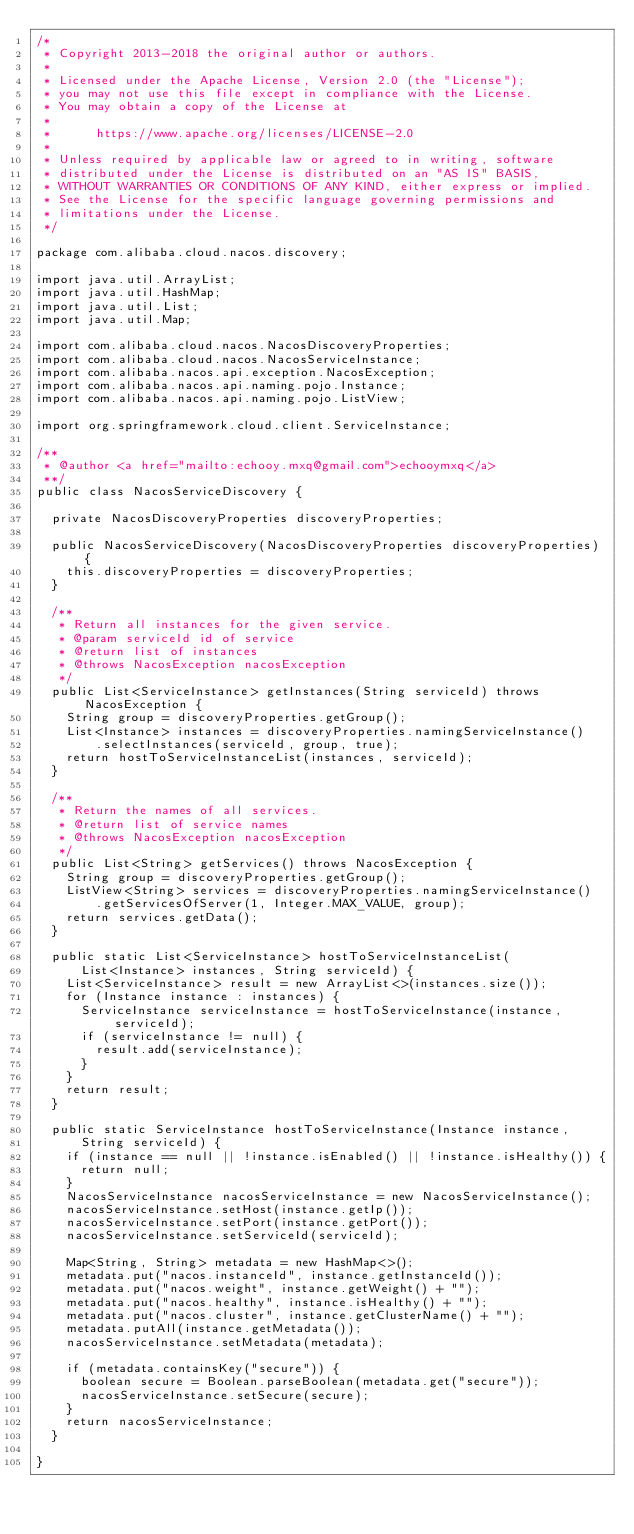<code> <loc_0><loc_0><loc_500><loc_500><_Java_>/*
 * Copyright 2013-2018 the original author or authors.
 *
 * Licensed under the Apache License, Version 2.0 (the "License");
 * you may not use this file except in compliance with the License.
 * You may obtain a copy of the License at
 *
 *      https://www.apache.org/licenses/LICENSE-2.0
 *
 * Unless required by applicable law or agreed to in writing, software
 * distributed under the License is distributed on an "AS IS" BASIS,
 * WITHOUT WARRANTIES OR CONDITIONS OF ANY KIND, either express or implied.
 * See the License for the specific language governing permissions and
 * limitations under the License.
 */

package com.alibaba.cloud.nacos.discovery;

import java.util.ArrayList;
import java.util.HashMap;
import java.util.List;
import java.util.Map;

import com.alibaba.cloud.nacos.NacosDiscoveryProperties;
import com.alibaba.cloud.nacos.NacosServiceInstance;
import com.alibaba.nacos.api.exception.NacosException;
import com.alibaba.nacos.api.naming.pojo.Instance;
import com.alibaba.nacos.api.naming.pojo.ListView;

import org.springframework.cloud.client.ServiceInstance;

/**
 * @author <a href="mailto:echooy.mxq@gmail.com">echooymxq</a>
 **/
public class NacosServiceDiscovery {

	private NacosDiscoveryProperties discoveryProperties;

	public NacosServiceDiscovery(NacosDiscoveryProperties discoveryProperties) {
		this.discoveryProperties = discoveryProperties;
	}

	/**
	 * Return all instances for the given service.
	 * @param serviceId id of service
	 * @return list of instances
	 * @throws NacosException nacosException
	 */
	public List<ServiceInstance> getInstances(String serviceId) throws NacosException {
		String group = discoveryProperties.getGroup();
		List<Instance> instances = discoveryProperties.namingServiceInstance()
				.selectInstances(serviceId, group, true);
		return hostToServiceInstanceList(instances, serviceId);
	}

	/**
	 * Return the names of all services.
	 * @return list of service names
	 * @throws NacosException nacosException
	 */
	public List<String> getServices() throws NacosException {
		String group = discoveryProperties.getGroup();
		ListView<String> services = discoveryProperties.namingServiceInstance()
				.getServicesOfServer(1, Integer.MAX_VALUE, group);
		return services.getData();
	}

	public static List<ServiceInstance> hostToServiceInstanceList(
			List<Instance> instances, String serviceId) {
		List<ServiceInstance> result = new ArrayList<>(instances.size());
		for (Instance instance : instances) {
			ServiceInstance serviceInstance = hostToServiceInstance(instance, serviceId);
			if (serviceInstance != null) {
				result.add(serviceInstance);
			}
		}
		return result;
	}

	public static ServiceInstance hostToServiceInstance(Instance instance,
			String serviceId) {
		if (instance == null || !instance.isEnabled() || !instance.isHealthy()) {
			return null;
		}
		NacosServiceInstance nacosServiceInstance = new NacosServiceInstance();
		nacosServiceInstance.setHost(instance.getIp());
		nacosServiceInstance.setPort(instance.getPort());
		nacosServiceInstance.setServiceId(serviceId);

		Map<String, String> metadata = new HashMap<>();
		metadata.put("nacos.instanceId", instance.getInstanceId());
		metadata.put("nacos.weight", instance.getWeight() + "");
		metadata.put("nacos.healthy", instance.isHealthy() + "");
		metadata.put("nacos.cluster", instance.getClusterName() + "");
		metadata.putAll(instance.getMetadata());
		nacosServiceInstance.setMetadata(metadata);

		if (metadata.containsKey("secure")) {
			boolean secure = Boolean.parseBoolean(metadata.get("secure"));
			nacosServiceInstance.setSecure(secure);
		}
		return nacosServiceInstance;
	}

}
</code> 